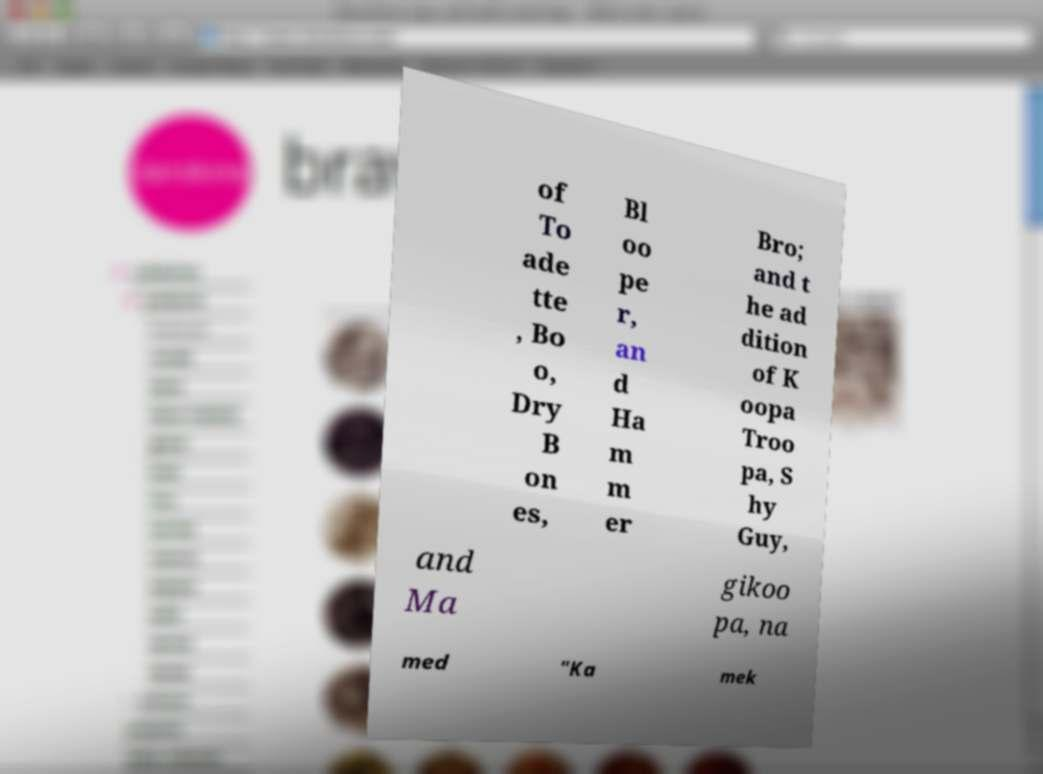For documentation purposes, I need the text within this image transcribed. Could you provide that? of To ade tte , Bo o, Dry B on es, Bl oo pe r, an d Ha m m er Bro; and t he ad dition of K oopa Troo pa, S hy Guy, and Ma gikoo pa, na med "Ka mek 